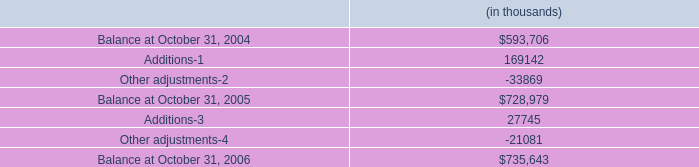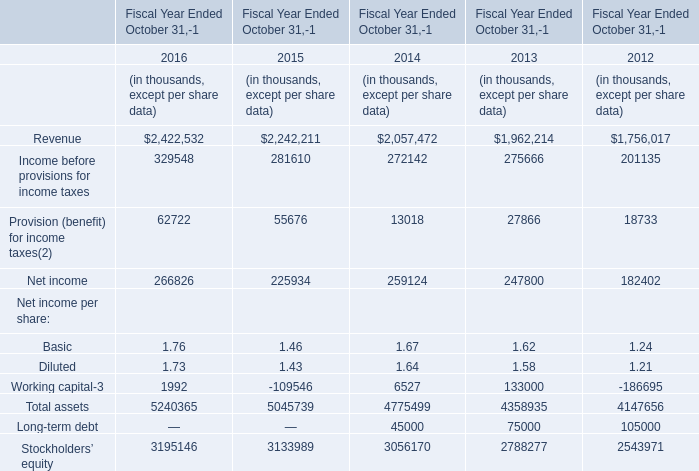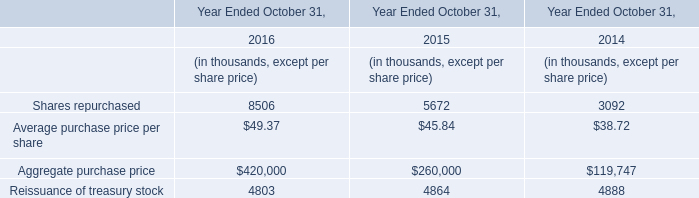what is the percentual increase observed in the balance between 2004 and 2005?\\n 
Computations: ((728979 / 593706) - 1)
Answer: 0.22785. 